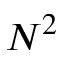Convert formula to latex. <formula><loc_0><loc_0><loc_500><loc_500>N ^ { 2 }</formula> 